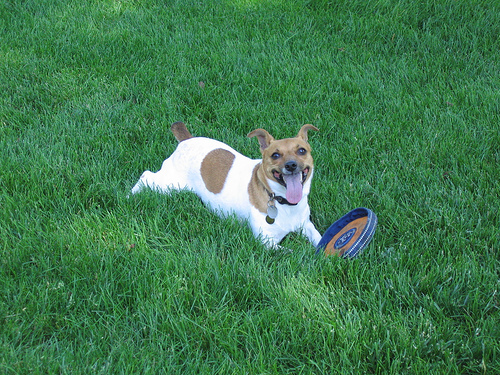<image>What type of dog is this? I don't know the specific type of the dog. However, it could be a terrier, Jack Russell terrier, boxer, or collie. What type of dog is this? I don't know what type of dog this is. It can be a mixed terrier, terrier, jack russell, jack russell terrier, boxer, or collie. 